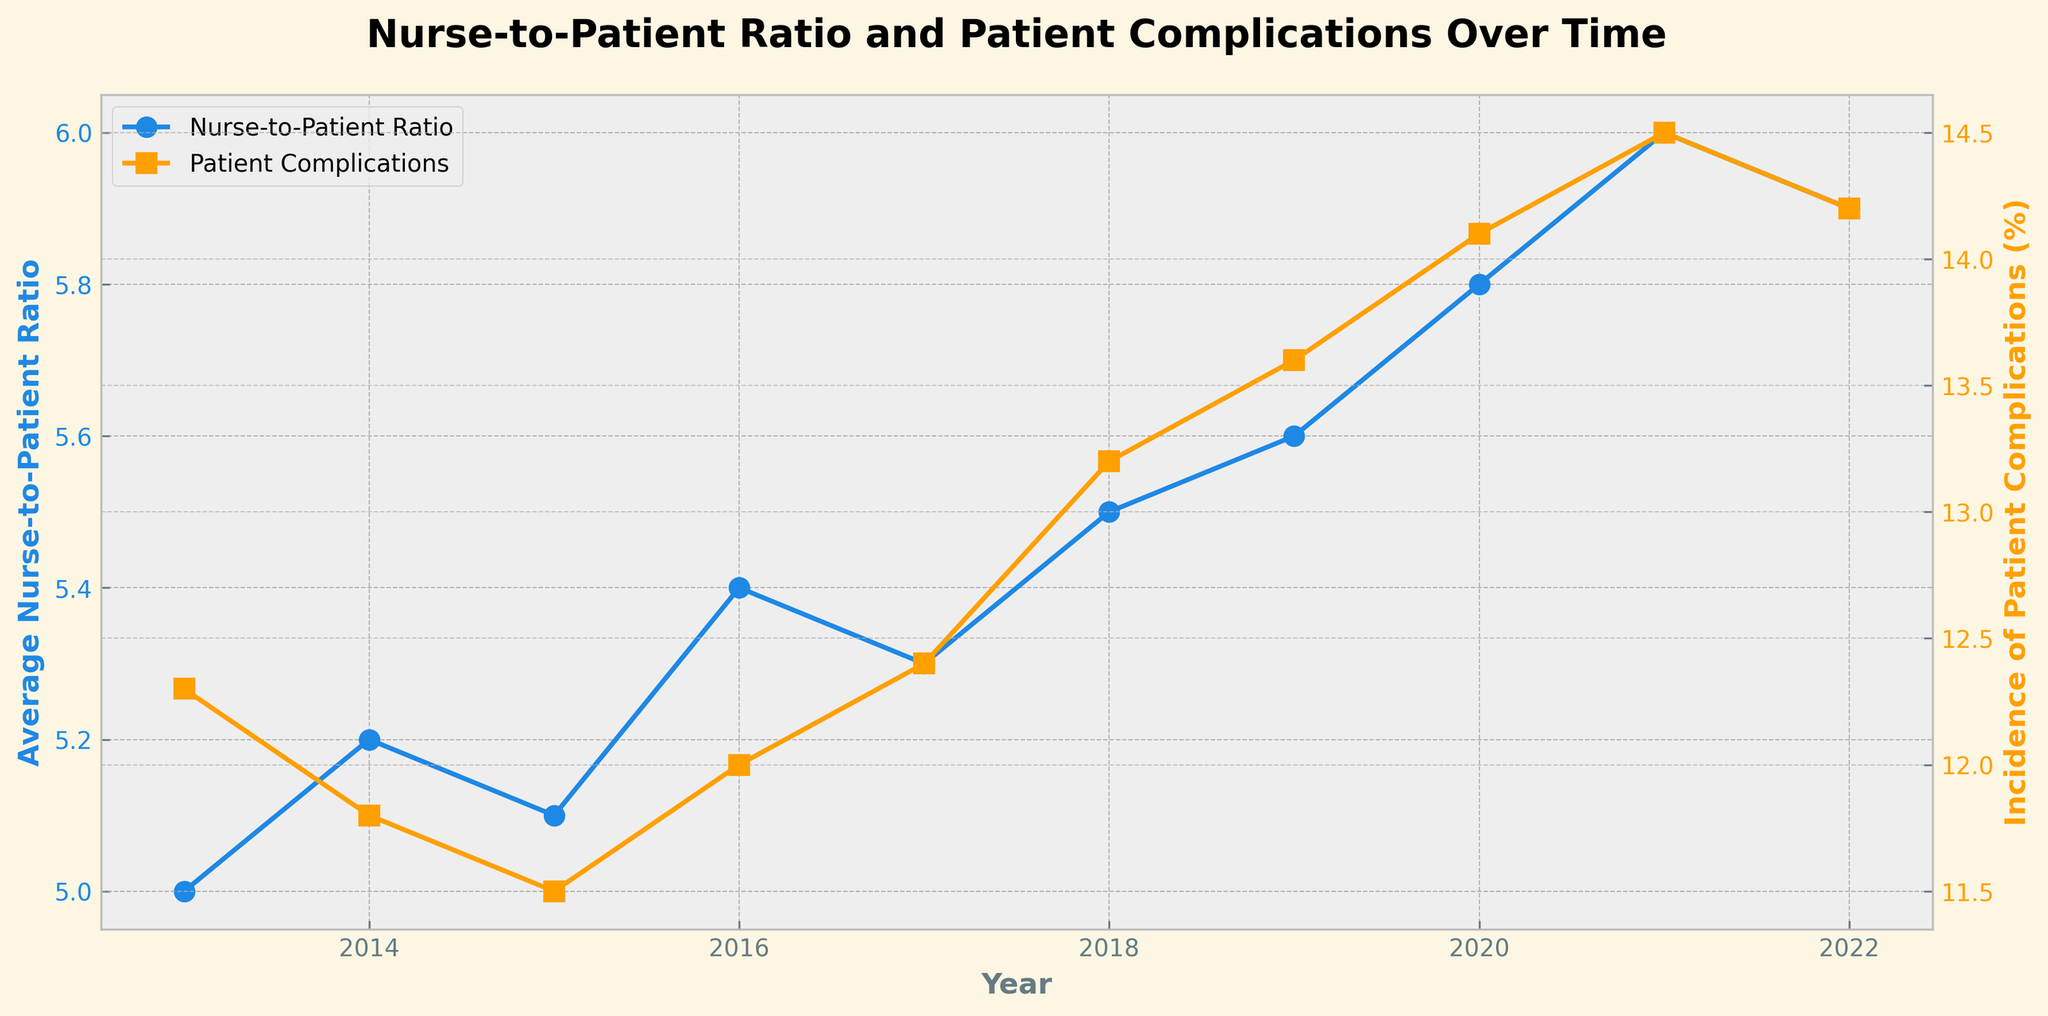What's the title of the figure? The title of the figure can be found at the top, displaying the main topic of the plot which summarizes the data represented.
Answer: Nurse-to-Patient Ratio and Patient Complications Over Time What are the two different data series shown in the plot? The figure has two y-axes, each representing different data series. One series is the Average Nurse-to-Patient Ratio, and the other is the Incidence of Patient Complications, based on the labels provided for each y-axis and legend entries.
Answer: Average Nurse-to-Patient Ratio, Incidence of Patient Complications How did the average nurse-to-patient ratio change from 2013 to 2022? By looking at the plotted line for the nurse-to-patient ratio, one can observe the ratio values for 2013 and 2022 and determine whether it increased or decreased. In 2013 it was 1:5, and by 2022 it became 1:5.9. This suggests an increase in the average number of patients per nurse over this period.
Answer: Increased What year saw the highest incidence of patient complications, and what was the rate? Examining the line representing Incidence of Patient Complications, the peak can be identified. The highest incidence occurred in 2021, with a rate of 14.5%.
Answer: 2021, 14.5% What is the trend in average nurse-to-patient ratio from 2013 to 2022? To establish the trend, one must observe the direction and pattern of the line for the nurse-to-patient ratio over the entire period. The ratio generally shows an increasing trend from 1:5 in 2013 to 1:5.9 in 2022.
Answer: Increasing What is the difference in the incidence of patient complications between 2013 and 2022? By noting the values at the start and end years for patient complications, it is possible to calculate the difference, from 12.3% in 2013 to 14.2% in 2022, the difference is 14.2% - 12.3%.
Answer: 1.9% Which year had the lowest incidence of patient complications? By scanning the line representing patient complications, identify the minimum value point. The lowest incidence is found in 2015, with a rate of 11.5%.
Answer: 2015 Describe the relationship between Average Nurse-to-Patient Ratio and Incidence of Patient Complications. Based on the trends, what can be inferred? The nurse-to-patient ratio has progressively increased, indicating more patients per nurse, while the incidence of complications also tends to increase over time. This correlation suggests that an increasing nurse-to-patient ratio may be associated with a higher incidence of patient complications.
Answer: Positive correlation In which year did the Average Nurse-to-Patient Ratio reach 1:6, and what was the corresponding incidence of patient complications? The Ratio reached 1:6 in the year 2021. The incidence value can be found in the plot for this specific year, which is 14.5%.
Answer: 2021, 14.5% 